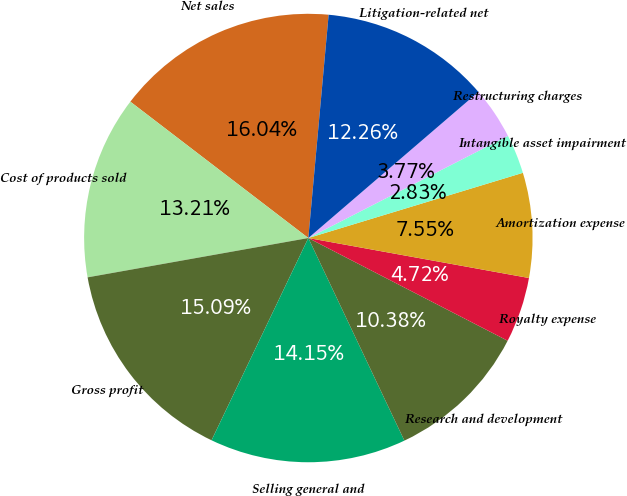<chart> <loc_0><loc_0><loc_500><loc_500><pie_chart><fcel>Net sales<fcel>Cost of products sold<fcel>Gross profit<fcel>Selling general and<fcel>Research and development<fcel>Royalty expense<fcel>Amortization expense<fcel>Intangible asset impairment<fcel>Restructuring charges<fcel>Litigation-related net<nl><fcel>16.04%<fcel>13.21%<fcel>15.09%<fcel>14.15%<fcel>10.38%<fcel>4.72%<fcel>7.55%<fcel>2.83%<fcel>3.77%<fcel>12.26%<nl></chart> 